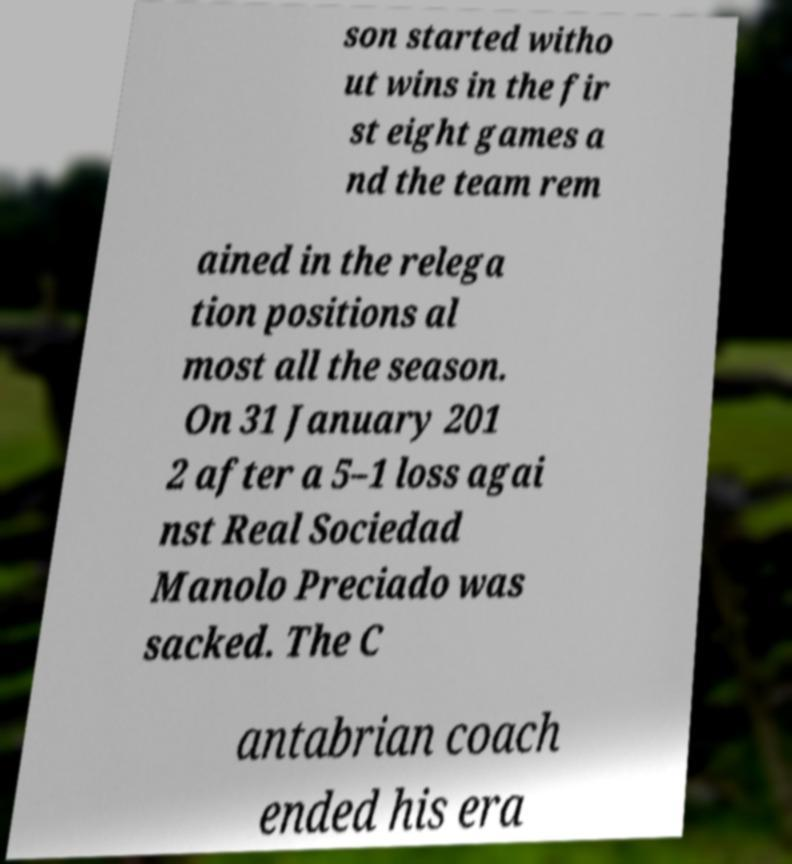Please read and relay the text visible in this image. What does it say? son started witho ut wins in the fir st eight games a nd the team rem ained in the relega tion positions al most all the season. On 31 January 201 2 after a 5–1 loss agai nst Real Sociedad Manolo Preciado was sacked. The C antabrian coach ended his era 